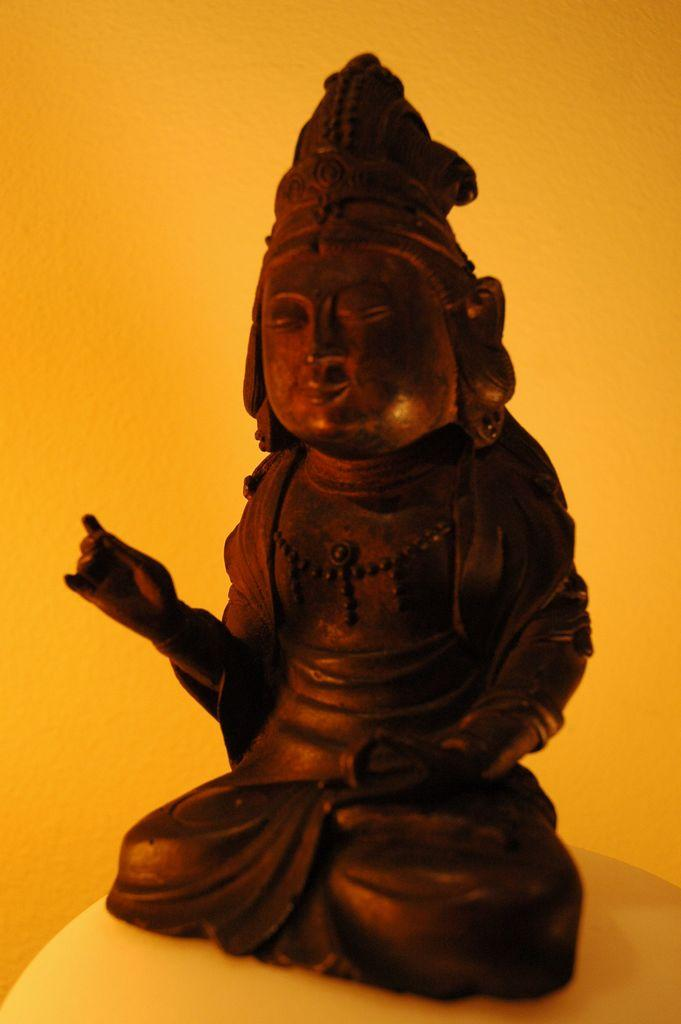What is the main subject in the center of the image? There is a statue in the center of the image. What is the statue resting on? The statue is on a surface. What color is the background of the image? The background of the image is orange colored. Can you tell me how many dimes are scattered around the statue in the image? There are no dimes present in the image; the focus is on the statue and its surroundings. 